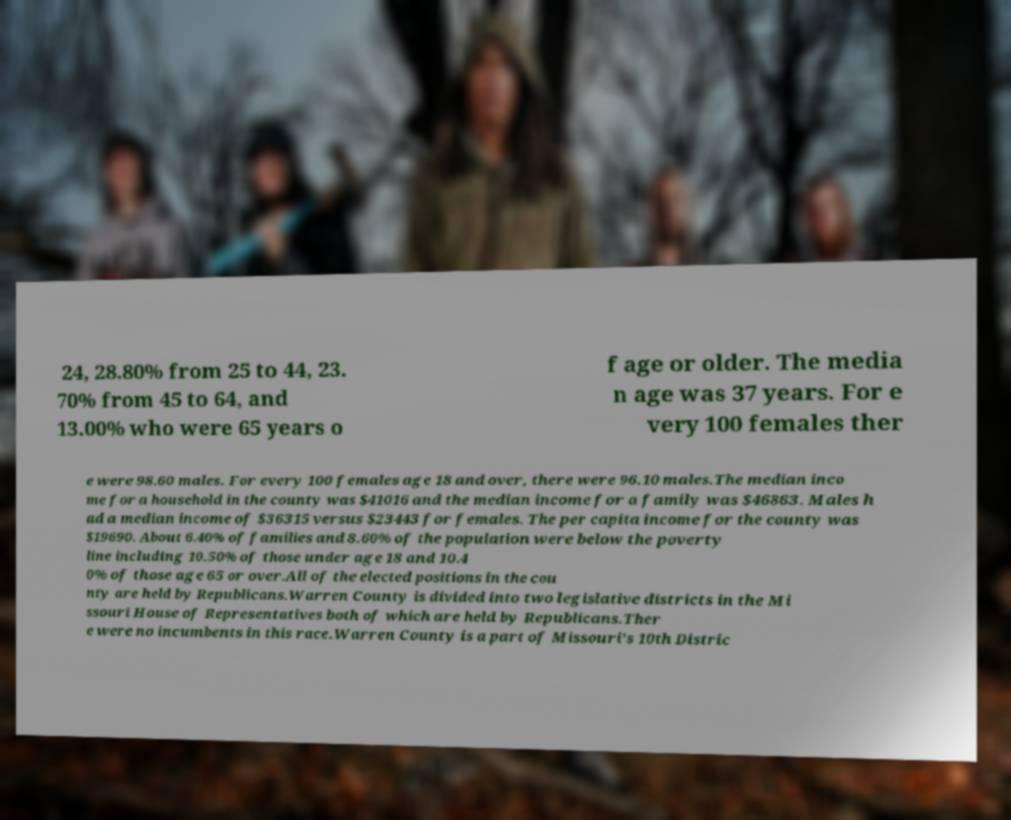There's text embedded in this image that I need extracted. Can you transcribe it verbatim? 24, 28.80% from 25 to 44, 23. 70% from 45 to 64, and 13.00% who were 65 years o f age or older. The media n age was 37 years. For e very 100 females ther e were 98.60 males. For every 100 females age 18 and over, there were 96.10 males.The median inco me for a household in the county was $41016 and the median income for a family was $46863. Males h ad a median income of $36315 versus $23443 for females. The per capita income for the county was $19690. About 6.40% of families and 8.60% of the population were below the poverty line including 10.50% of those under age 18 and 10.4 0% of those age 65 or over.All of the elected positions in the cou nty are held by Republicans.Warren County is divided into two legislative districts in the Mi ssouri House of Representatives both of which are held by Republicans.Ther e were no incumbents in this race.Warren County is a part of Missouri's 10th Distric 